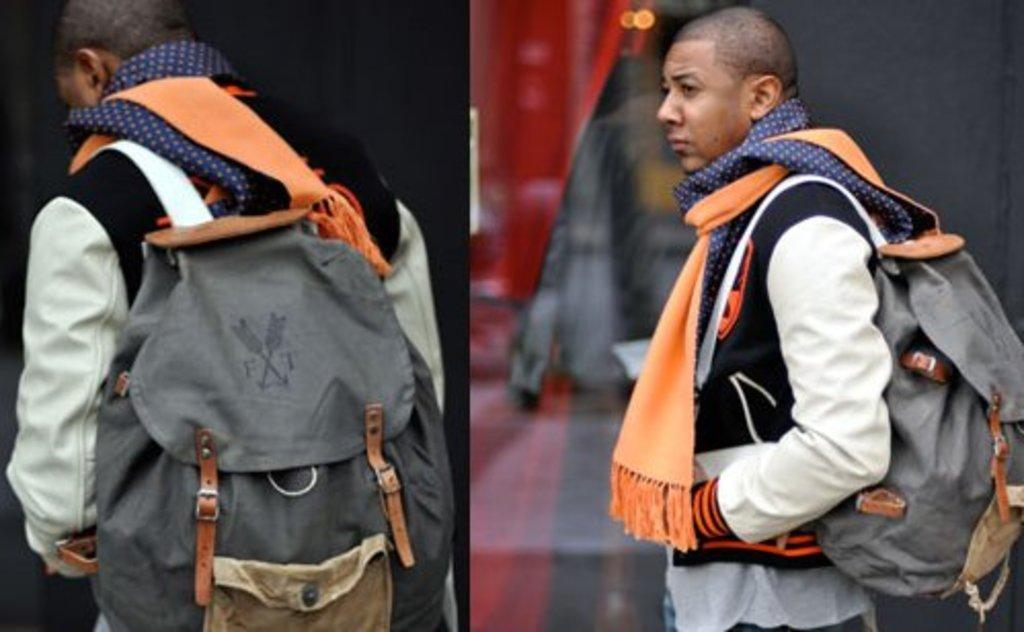How many people are in the image? There are two persons in the image. What are the people wearing on their bodies? Both persons are wearing a bag. What type of accessory is worn around their necks? Both persons are wearing a red color scarf. What is the smell of the baseball in the image? There is no baseball present in the image, so it is not possible to determine its smell. 